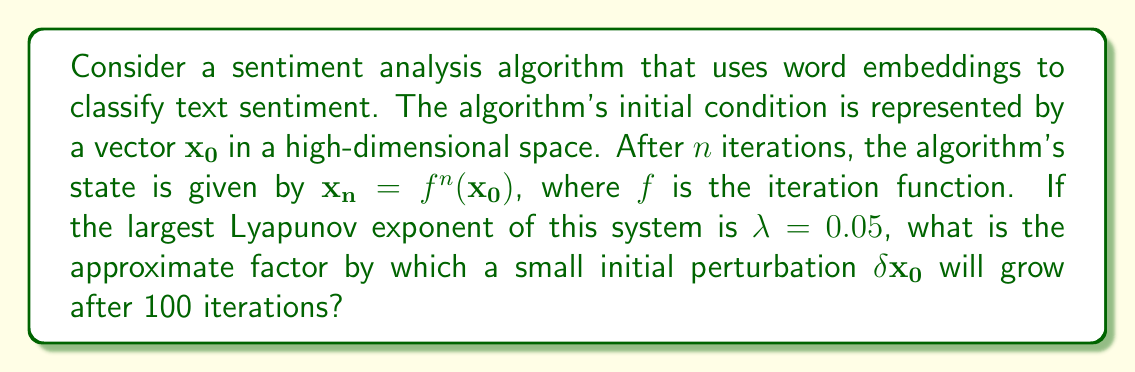Teach me how to tackle this problem. To solve this problem, we'll use the definition of the Lyapunov exponent and its relationship to the growth of perturbations in a dynamical system:

1) The Lyapunov exponent $\lambda$ is defined as:

   $$\lambda = \lim_{n \to \infty} \frac{1}{n} \ln \frac{|\delta\mathbf{x_n}|}{|\delta\mathbf{x_0}|}$$

   where $\delta\mathbf{x_n}$ is the perturbation after $n$ iterations.

2) We can rearrange this to express the growth of perturbations:

   $$|\delta\mathbf{x_n}| \approx |\delta\mathbf{x_0}| e^{\lambda n}$$

3) In this case, we're given:
   - $\lambda = 0.05$
   - $n = 100$

4) Substituting these values:

   $$|\delta\mathbf{x_{100}}| \approx |\delta\mathbf{x_0}| e^{0.05 \cdot 100}$$

5) Simplify:

   $$|\delta\mathbf{x_{100}}| \approx |\delta\mathbf{x_0}| e^5$$

6) Calculate $e^5$:

   $$e^5 \approx 148.4$$

Therefore, after 100 iterations, a small initial perturbation will grow by a factor of approximately 148.4.
Answer: 148.4 